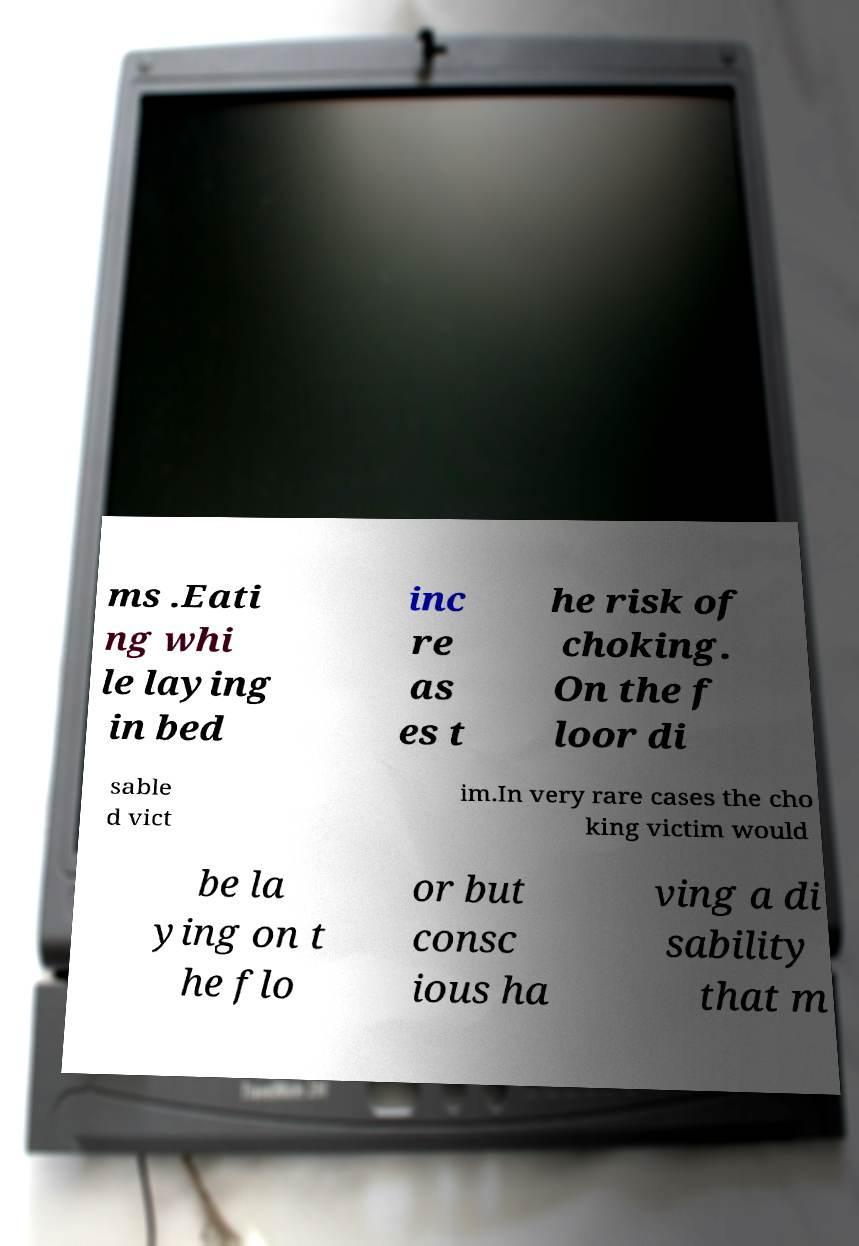Please read and relay the text visible in this image. What does it say? ms .Eati ng whi le laying in bed inc re as es t he risk of choking. On the f loor di sable d vict im.In very rare cases the cho king victim would be la ying on t he flo or but consc ious ha ving a di sability that m 